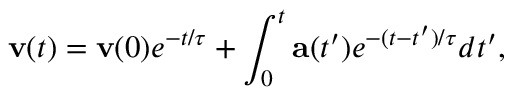<formula> <loc_0><loc_0><loc_500><loc_500>v ( t ) = v ( 0 ) e ^ { - t / \tau } + \int _ { 0 } ^ { t } a ( t ^ { \prime } ) e ^ { - ( t - t ^ { \prime } ) / \tau } d t ^ { \prime } ,</formula> 